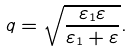<formula> <loc_0><loc_0><loc_500><loc_500>q = \sqrt { \frac { \varepsilon _ { 1 } \varepsilon } { \varepsilon _ { 1 } + \varepsilon } } .</formula> 